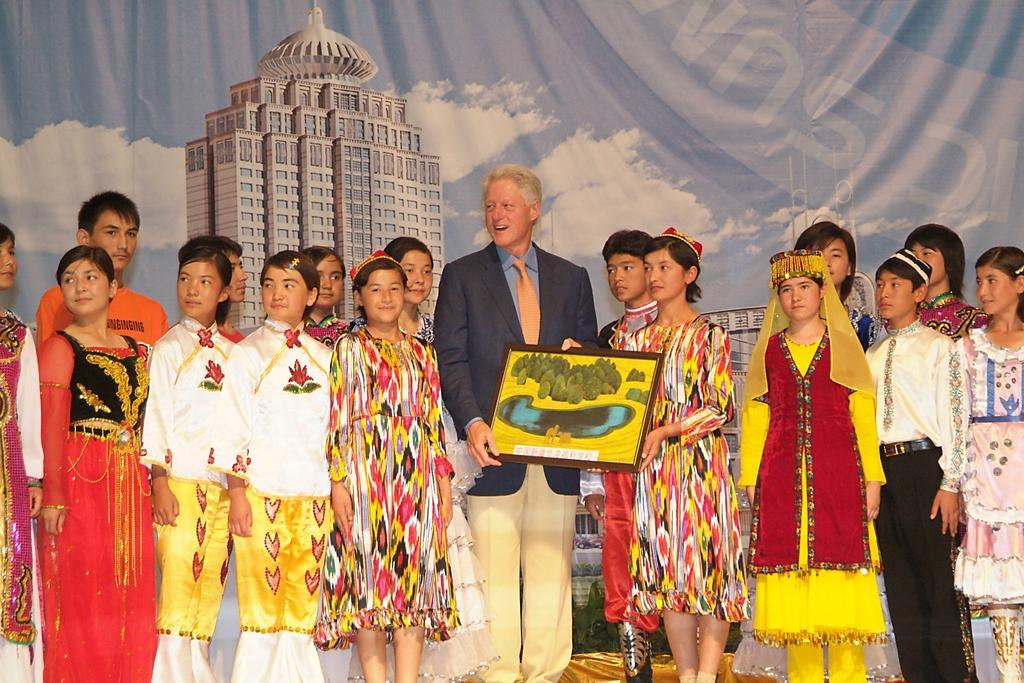Can you describe this image briefly? There is a group of persons standing in the middle of this image. There is a painted curtain is in the background. The person standing in middle is holding a frame. 